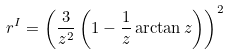<formula> <loc_0><loc_0><loc_500><loc_500>r ^ { I } = \left ( \frac { 3 } { z ^ { 2 } } \left ( 1 - \frac { 1 } { z } \arctan z \right ) \right ) ^ { 2 }</formula> 